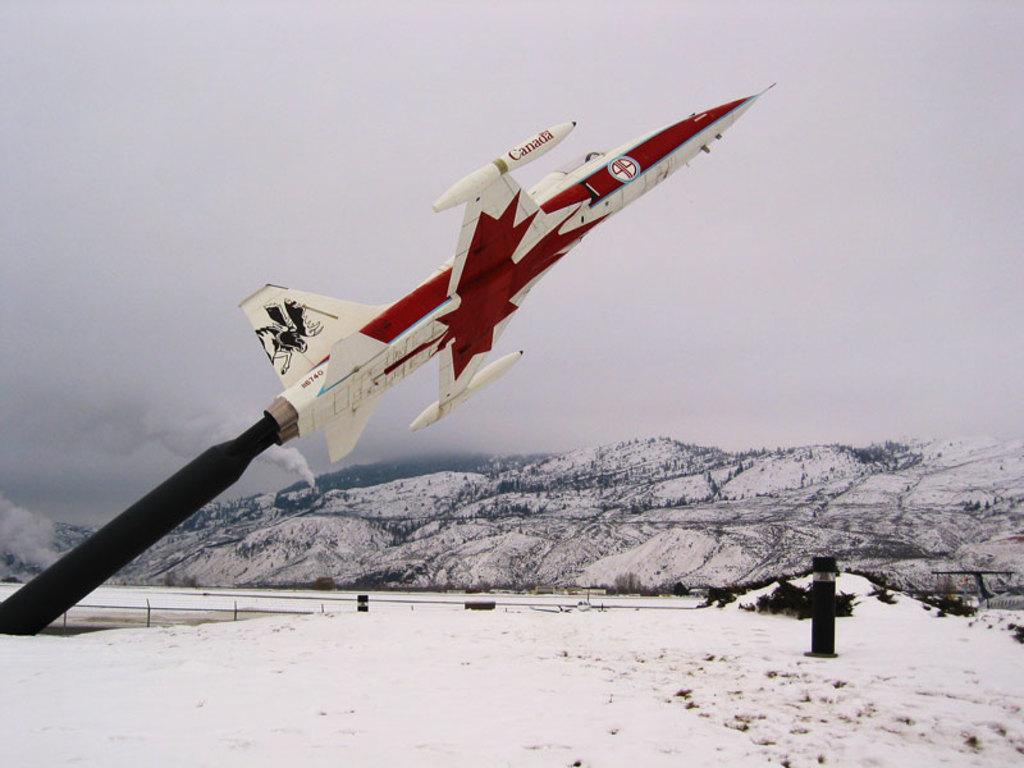What is the main subject of the image? There is a rocket in the image. What can be seen on the ground in the image? There is snow on the ground and a black color object in the image. What is visible at the top of the image? The sky is visible at the top of the image. What type of stage can be seen in the image? There is no stage present in the image. 